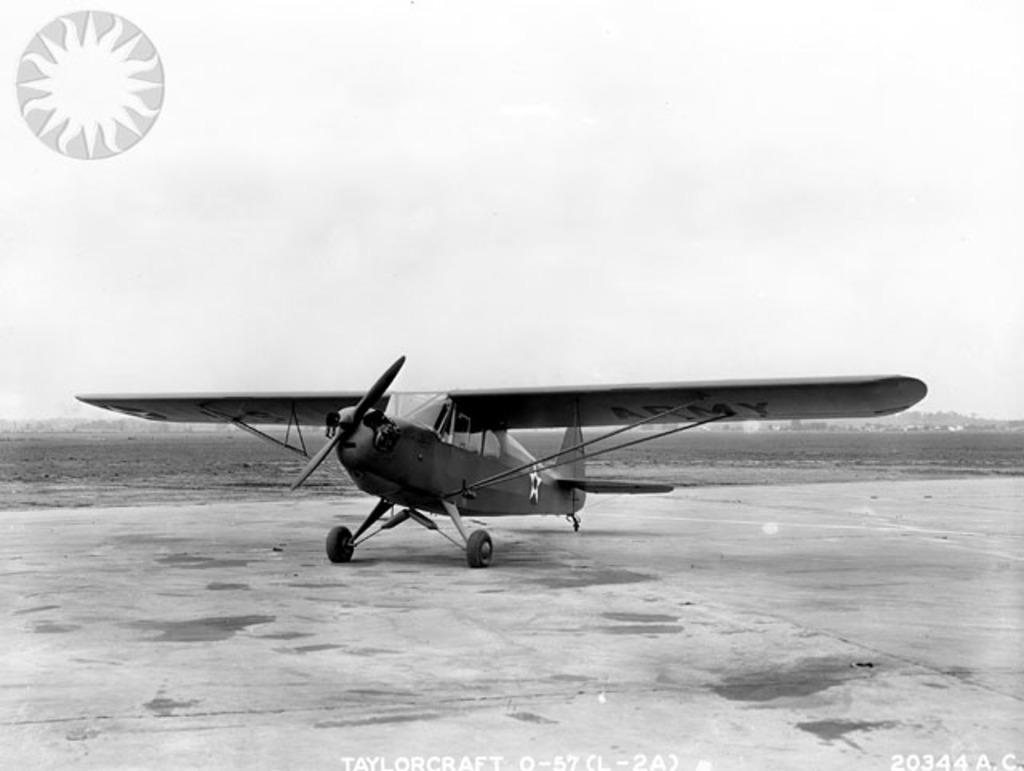What is the main subject of the image? The main subject of the image is an aeroplane. Where is the aeroplane located in the image? The aeroplane is on the ground in the image. What additional features can be seen in the image? There is a logo and a watermark in the image. What is the color scheme of the image? The image is black and white in color. What type of body is visible in the image? There is no body present in the image; it features an aeroplane on the ground with a logo and watermark. How does the aeroplane express regret in the image? The aeroplane does not express regret in the image, as it is an inanimate object and cannot experience emotions. 